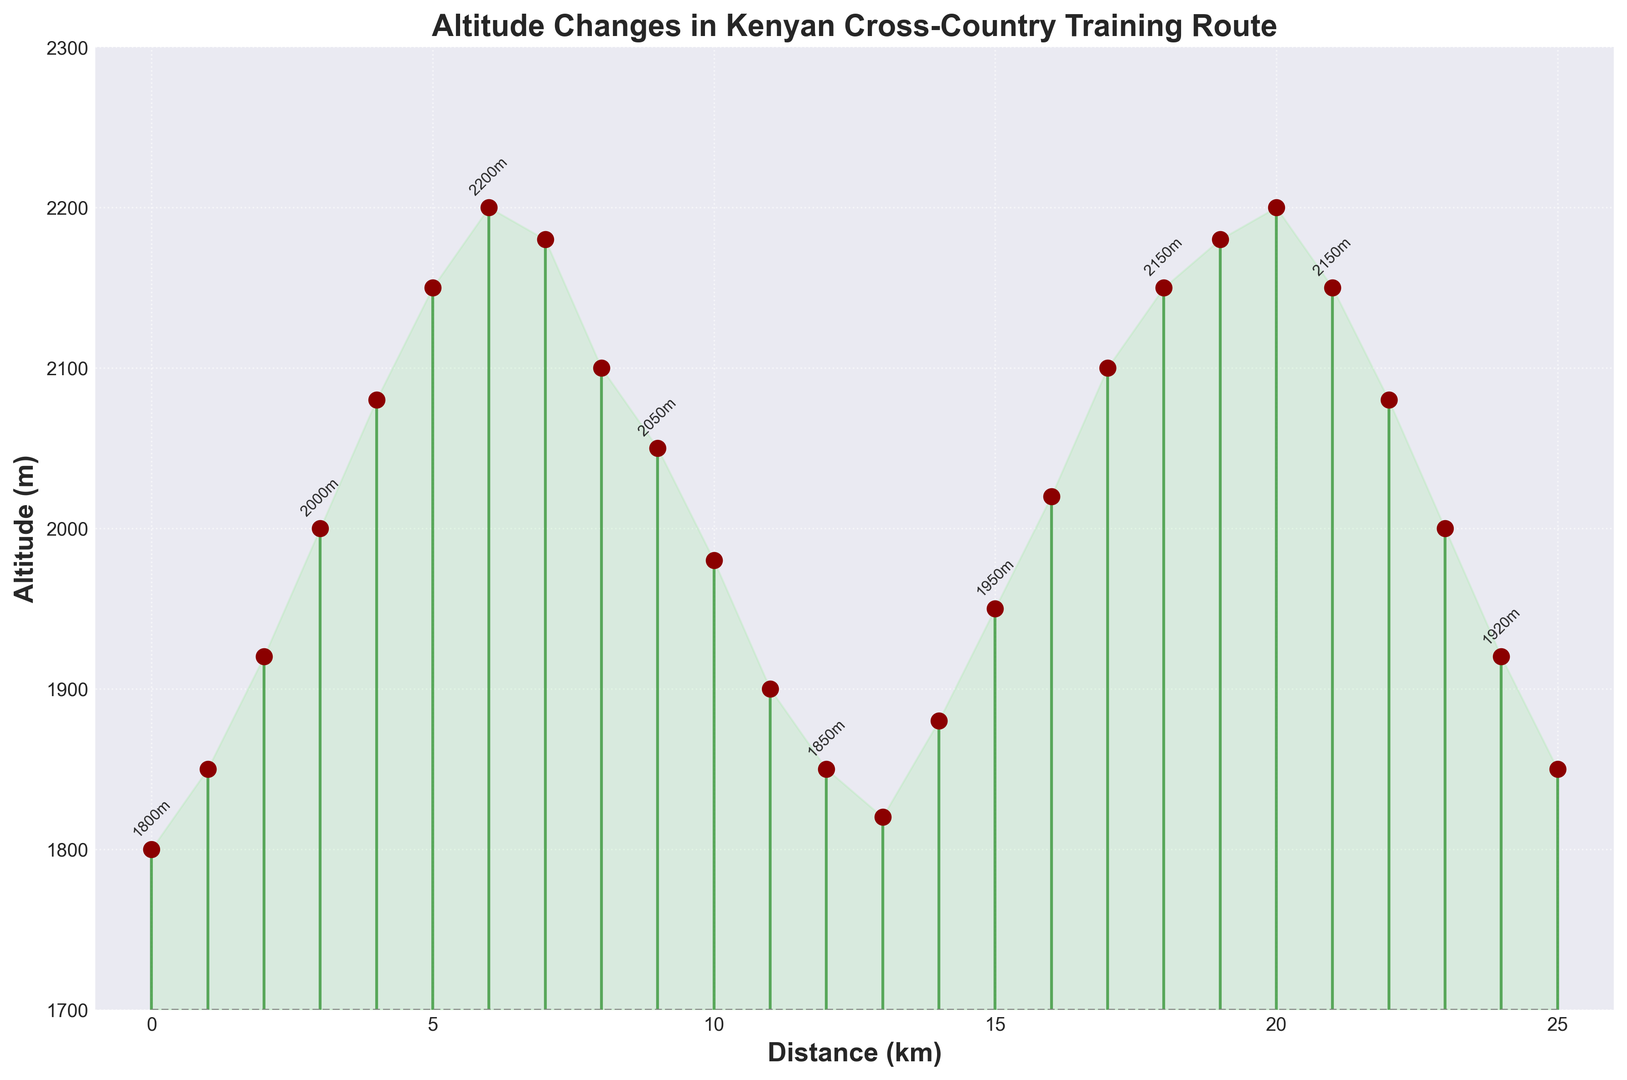What is the initial altitude at the start of the training route? At the start of the training route (distance = 0 km), the altitude is 1800 meters
Answer: 1800 meters What is the maximum altitude reached during the training route? The highest point in the plot corresponds to distance points such as 6 km and 20 km, where the altitude reaches 2200 meters
Answer: 2200 meters How does the altitude change between 0 km and 10 km? From 0 km to 5 km, the altitude increases from 1800 meters to 2150 meters. Then, from 5 km to 10 km, the altitude decreases from 2150 meters to 1980 meters
Answer: Increases then decreases What is the difference in altitude between the highest and the lowest points along the route? The maximum altitude is 2200 meters, and the minimum altitude is 1800 meters. So, the difference is 2200 meters - 1800 meters = 400 meters
Answer: 400 meters At which distances does the altitude reach 2100 meters? Looking at the stem plot, the altitude reaches 2100 meters at 8 km and 17 km
Answer: 8 km and 17 km How does the altitude change from 18 km to 22 km? From 18 km to 20 km, the altitude increases from 2150 meters to 2200 meters. Then, it decreases from 2200 meters at 20 km to 2080 meters at 22 km
Answer: Increases then decreases What is the average altitude from 12 km to 16 km? The altitudes at 12 km, 13 km, 14 km, 15 km, and 16 km are 1850, 1820, 1880, 1950, and 2020 meters respectively. So, the average is (1850 + 1820 + 1880 + 1950 + 2020) / 5 = 9500 / 5 = 1900 meters
Answer: 1900 meters Which section of the route shows a steady decline in altitude? From 7 km to 11 km, the altitude decreases steadily from 2180 meters to 1850 meters without any increase
Answer: 7 km to 11 km 